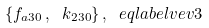<formula> <loc_0><loc_0><loc_500><loc_500>\{ f _ { a 3 0 } \, , \ k _ { 2 3 0 } \} \, , \ e q l a b e l { v e v 3 }</formula> 